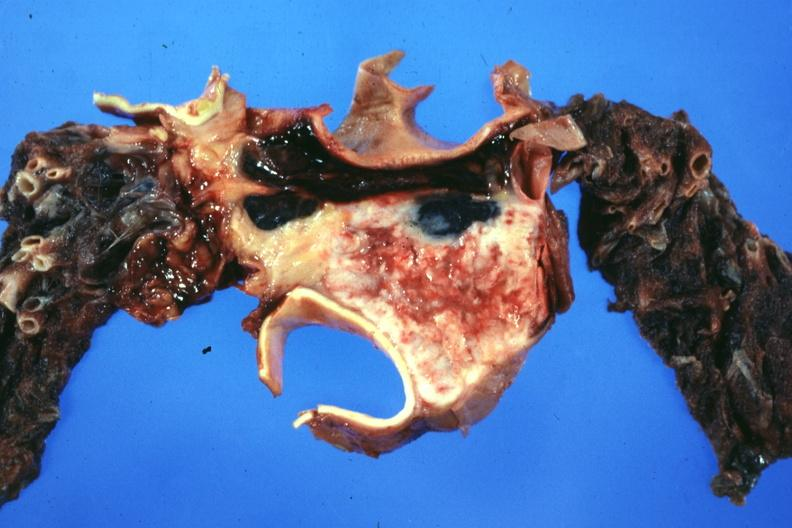where is this part in?
Answer the question using a single word or phrase. Thymus 